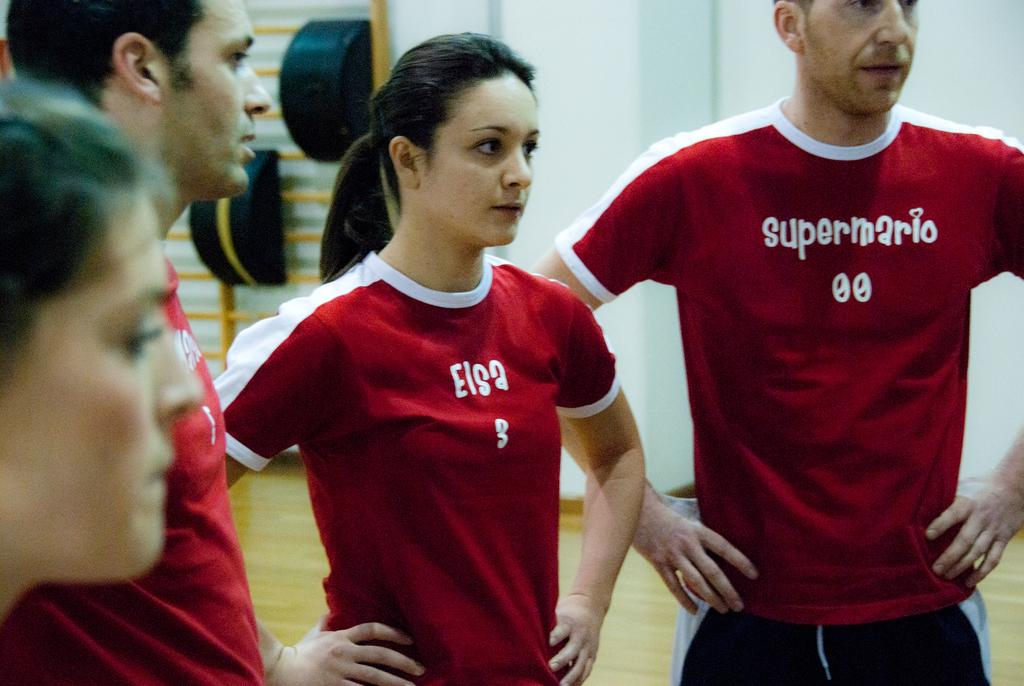<image>
Offer a succinct explanation of the picture presented. Elsa and SuperMario read the t shirts of these two participants. 